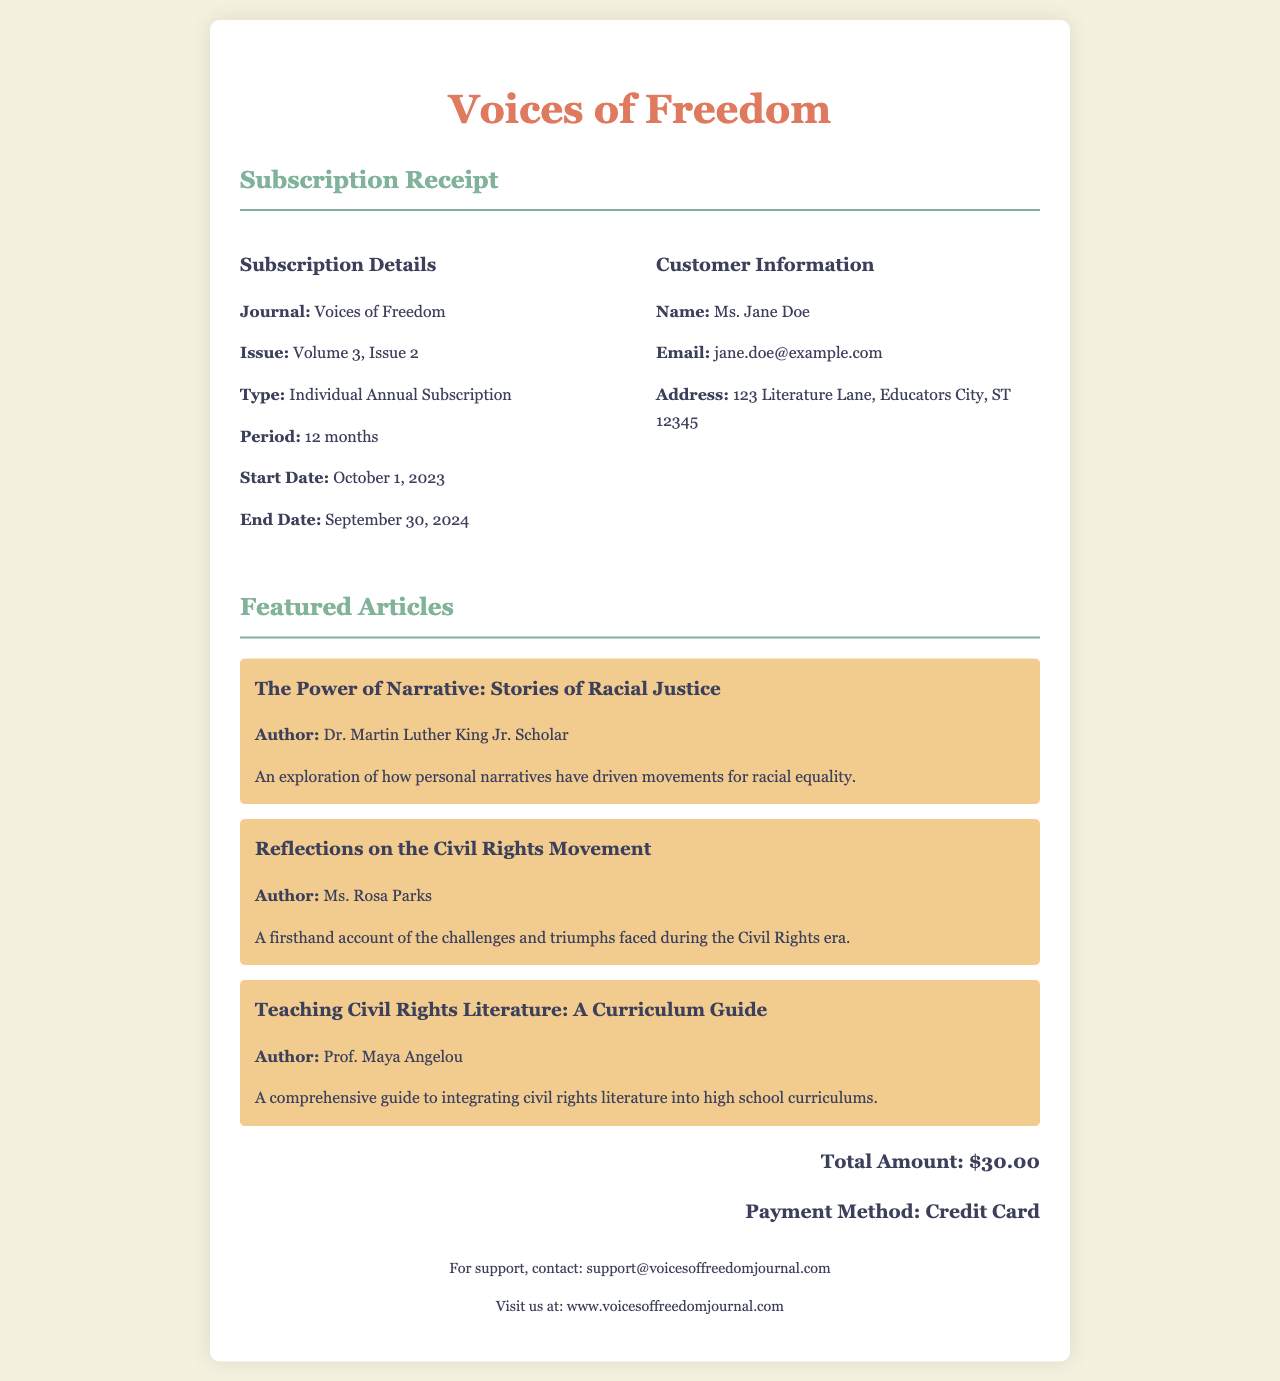What is the journal name? The journal name is specified in the header of the receipt, which is "Voices of Freedom."
Answer: Voices of Freedom What is the subscription type? The subscription type is listed under Subscription Details, which states "Individual Annual Subscription."
Answer: Individual Annual Subscription Who is the author of the article "The Power of Narrative: Stories of Racial Justice"? The author is mentioned with the article title in the featured articles section, which is "Dr. Martin Luther King Jr. Scholar."
Answer: Dr. Martin Luther King Jr. Scholar What is the total amount for the subscription? The total amount is found at the end of the receipt, which states "$30.00."
Answer: $30.00 What is the email address of the customer? The customer's email address is clearly provided under Customer Information, which is "jane.doe@example.com."
Answer: jane.doe@example.com What is the period of the subscription? The subscription period is indicated in the Subscription Details as "12 months."
Answer: 12 months What are the start and end dates of the subscription? Both dates are located in Subscription Details: Start Date is "October 1, 2023" and End Date is "September 30, 2024."
Answer: October 1, 2023 and September 30, 2024 What is the payment method used for the subscription? The payment method is specified in the total section, stating "Credit Card."
Answer: Credit Card What is the title of the comprehensive guide article? The title of the article is presented in the featured articles section, which is "Teaching Civil Rights Literature: A Curriculum Guide."
Answer: Teaching Civil Rights Literature: A Curriculum Guide 